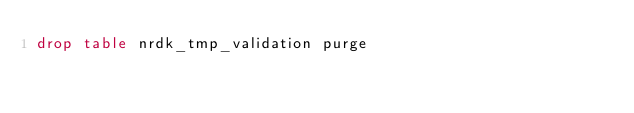Convert code to text. <code><loc_0><loc_0><loc_500><loc_500><_SQL_>drop table nrdk_tmp_validation purge</code> 